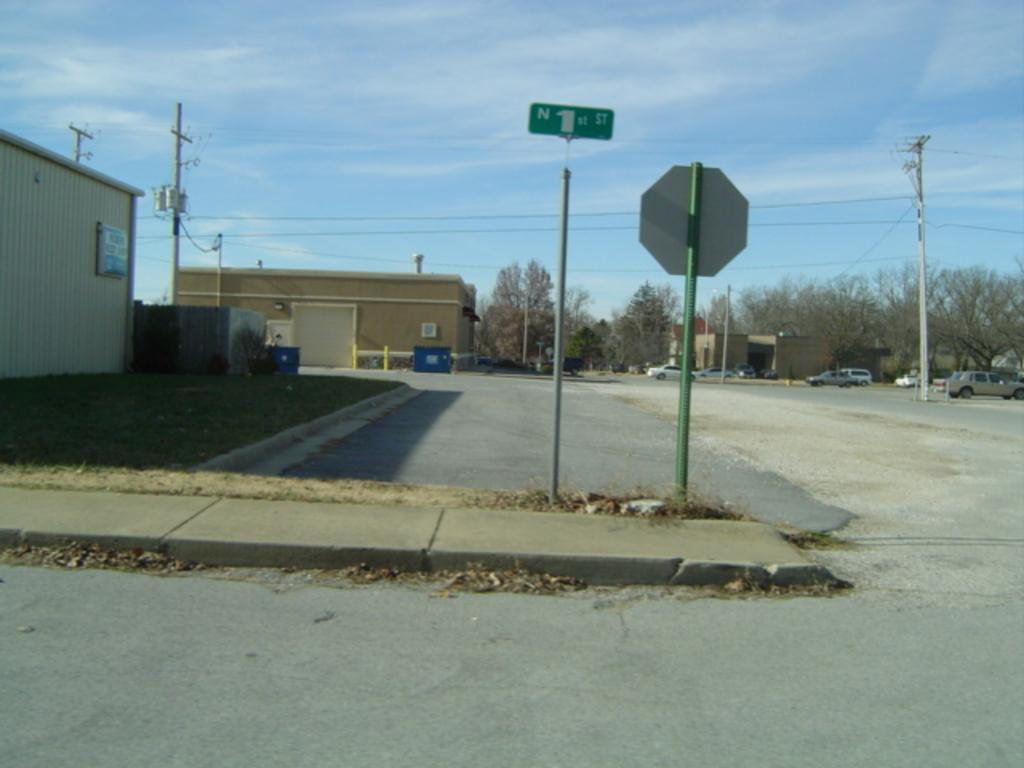What can be seen on the road in the image? There are vehicles on the road in the image. What structures are present in the image? There are poles, boards, houses, and trees in the image. What type of vegetation is visible in the image? There is grass and trees in the image. What is visible in the background of the image? The sky is visible in the background of the image. How much sugar is being consumed by the bee in the image? There is no bee present in the image, so it is not possible to determine how much sugar is being consumed. What time of day is it in the image, given the presence of morning? The provided facts do not mention the time of day or any reference to morning, so it cannot be determined from the image. 